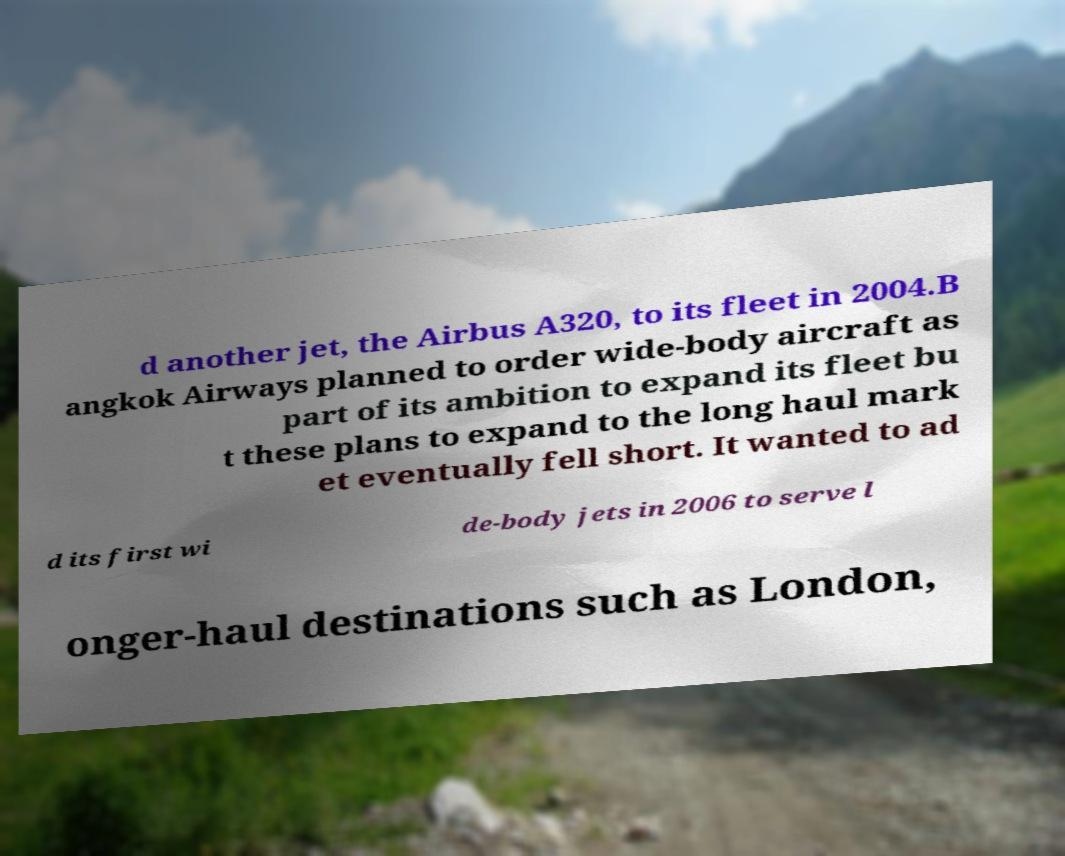Could you assist in decoding the text presented in this image and type it out clearly? d another jet, the Airbus A320, to its fleet in 2004.B angkok Airways planned to order wide-body aircraft as part of its ambition to expand its fleet bu t these plans to expand to the long haul mark et eventually fell short. It wanted to ad d its first wi de-body jets in 2006 to serve l onger-haul destinations such as London, 